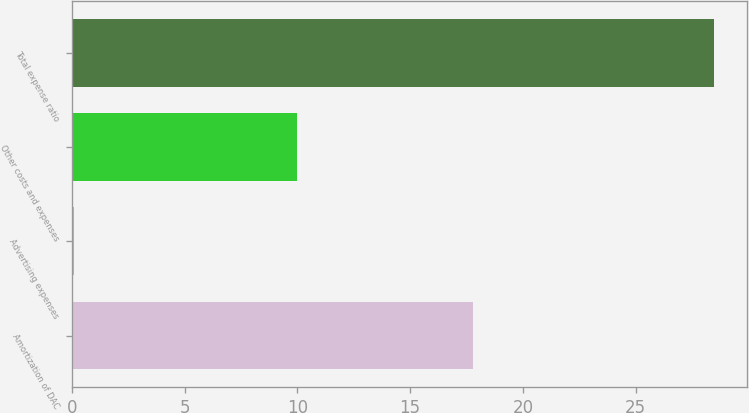Convert chart. <chart><loc_0><loc_0><loc_500><loc_500><bar_chart><fcel>Amortization of DAC<fcel>Advertising expenses<fcel>Other costs and expenses<fcel>Total expense ratio<nl><fcel>17.8<fcel>0.1<fcel>10<fcel>28.5<nl></chart> 